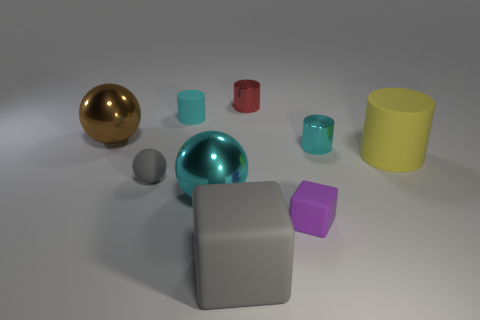Subtract 2 spheres. How many spheres are left? 1 Subtract all gray blocks. How many red balls are left? 0 Subtract all tiny yellow matte spheres. Subtract all cyan cylinders. How many objects are left? 7 Add 7 large brown balls. How many large brown balls are left? 8 Add 3 cyan rubber objects. How many cyan rubber objects exist? 4 Subtract all red cylinders. How many cylinders are left? 3 Subtract all metal balls. How many balls are left? 1 Subtract 1 red cylinders. How many objects are left? 8 Subtract all blocks. How many objects are left? 7 Subtract all brown spheres. Subtract all gray blocks. How many spheres are left? 2 